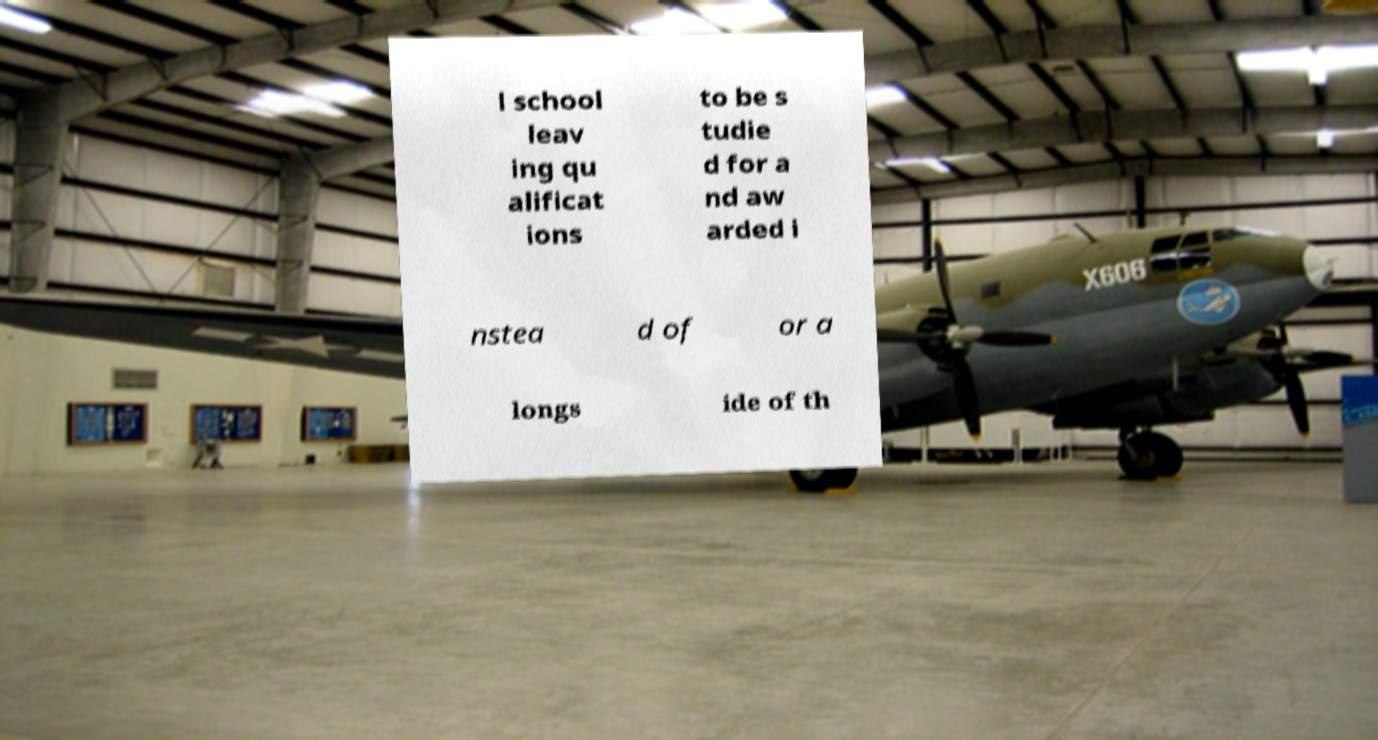Could you extract and type out the text from this image? l school leav ing qu alificat ions to be s tudie d for a nd aw arded i nstea d of or a longs ide of th 